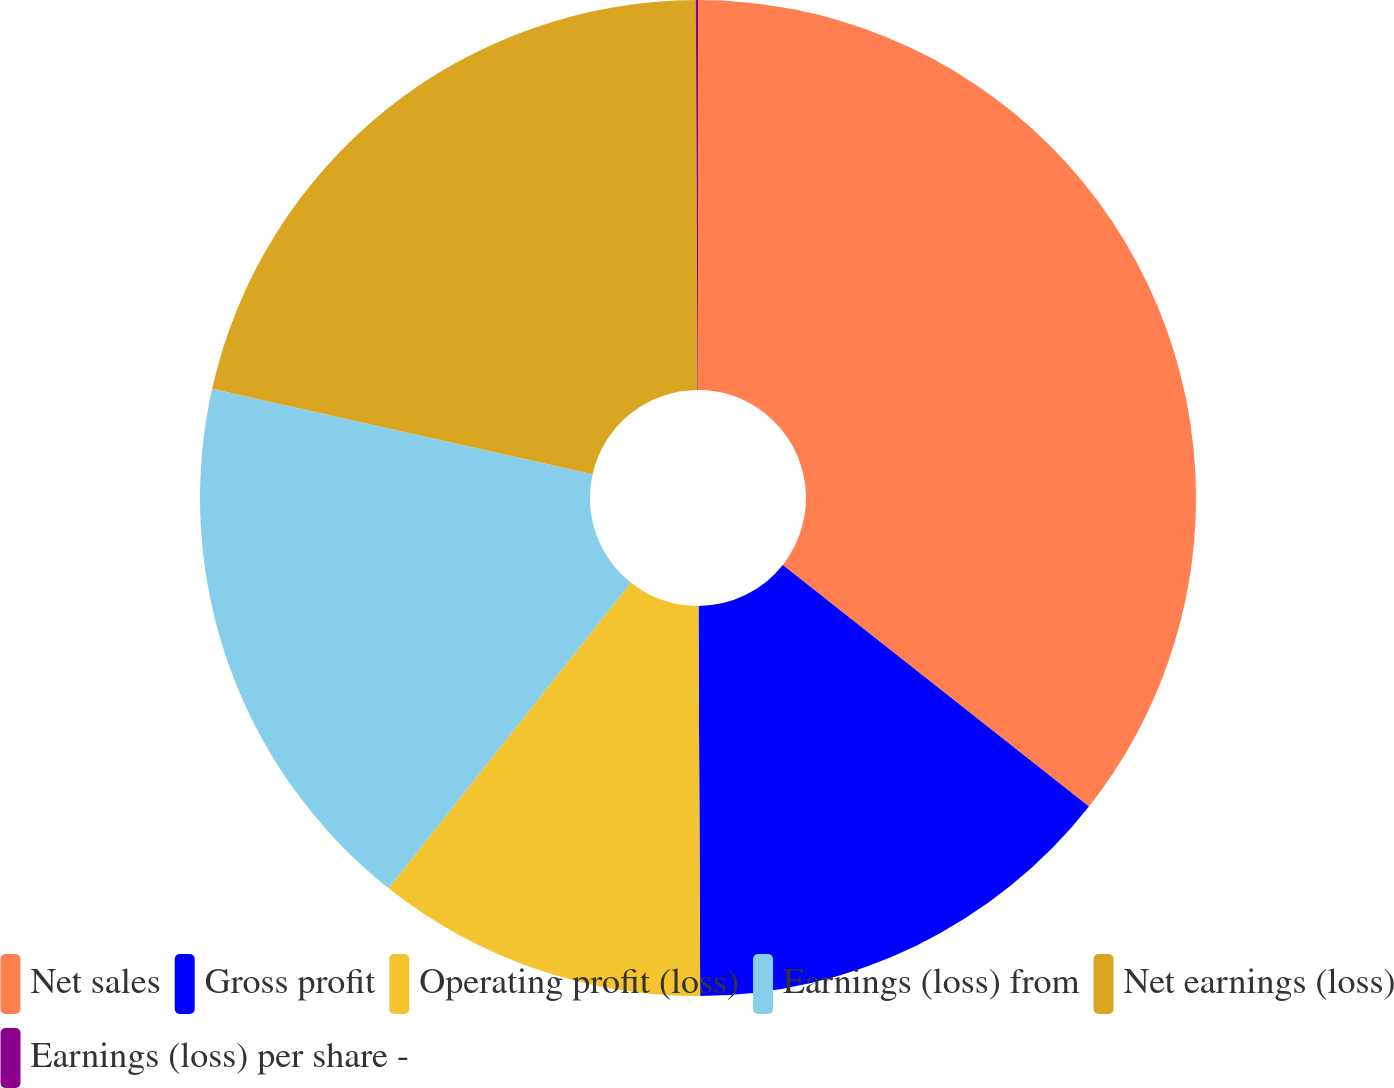Convert chart to OTSL. <chart><loc_0><loc_0><loc_500><loc_500><pie_chart><fcel>Net sales<fcel>Gross profit<fcel>Operating profit (loss)<fcel>Earnings (loss) from<fcel>Net earnings (loss)<fcel>Earnings (loss) per share -<nl><fcel>35.63%<fcel>14.3%<fcel>10.74%<fcel>17.85%<fcel>21.41%<fcel>0.07%<nl></chart> 